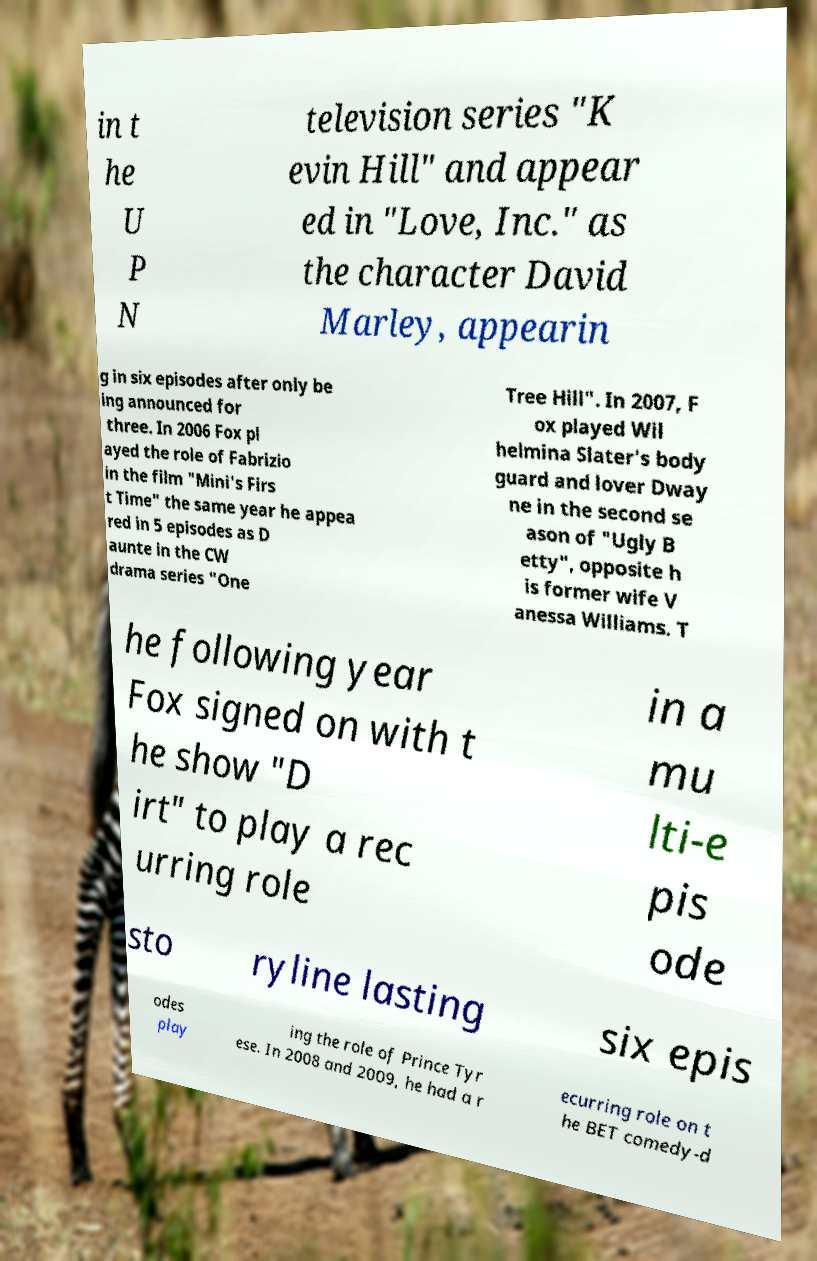There's text embedded in this image that I need extracted. Can you transcribe it verbatim? in t he U P N television series "K evin Hill" and appear ed in "Love, Inc." as the character David Marley, appearin g in six episodes after only be ing announced for three. In 2006 Fox pl ayed the role of Fabrizio in the film "Mini's Firs t Time" the same year he appea red in 5 episodes as D aunte in the CW drama series "One Tree Hill". In 2007, F ox played Wil helmina Slater's body guard and lover Dway ne in the second se ason of "Ugly B etty", opposite h is former wife V anessa Williams. T he following year Fox signed on with t he show "D irt" to play a rec urring role in a mu lti-e pis ode sto ryline lasting six epis odes play ing the role of Prince Tyr ese. In 2008 and 2009, he had a r ecurring role on t he BET comedy-d 